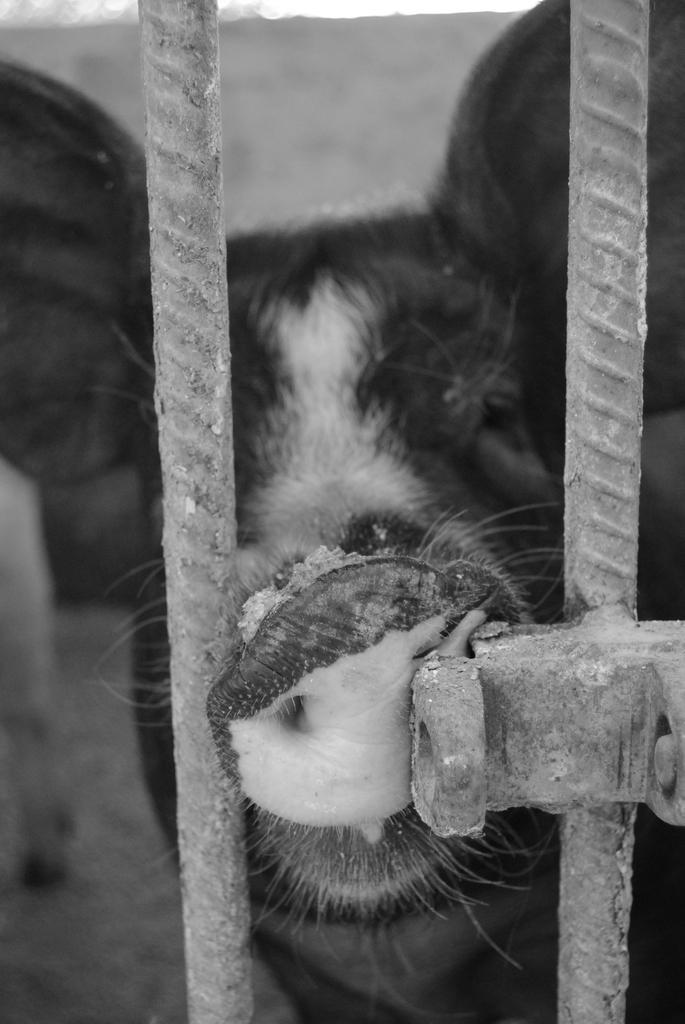Can you describe this image briefly? In this image in the front there are metal rods. In the center there is an animal. In the background there is a wall. 